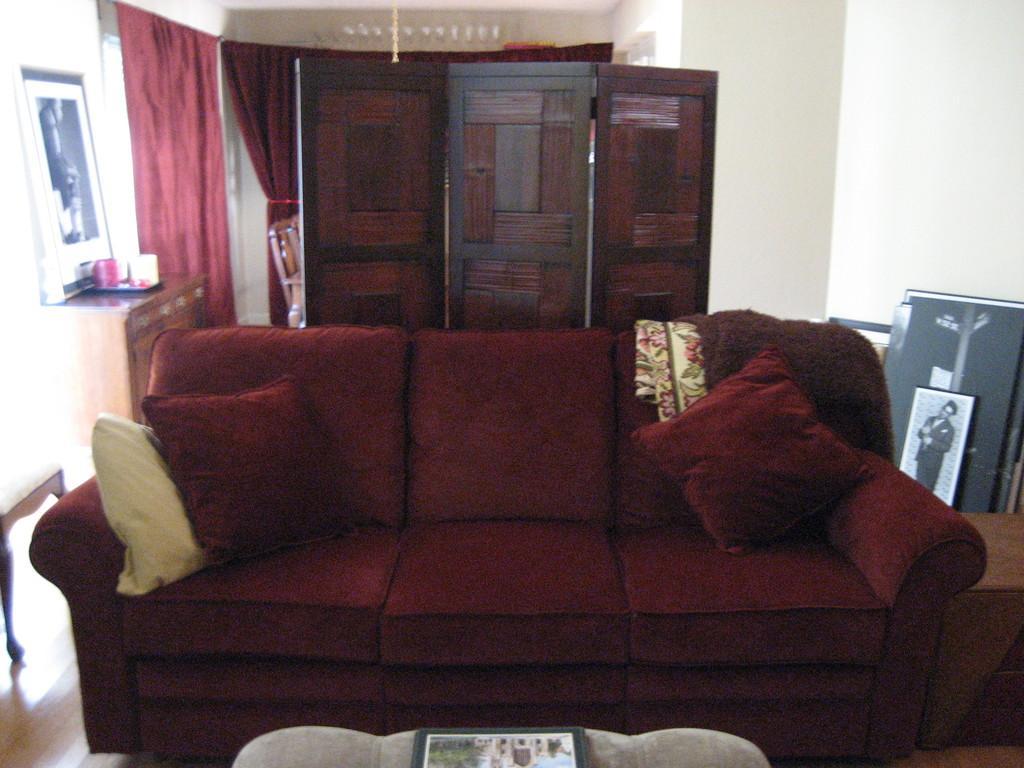Can you describe this image briefly? In this picture there is a sofa on which some pillows were placed. In the background, there are some wooden walls, curtains, photo frames. We can observe a wall here. 